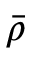<formula> <loc_0><loc_0><loc_500><loc_500>\ B a r { \rho }</formula> 